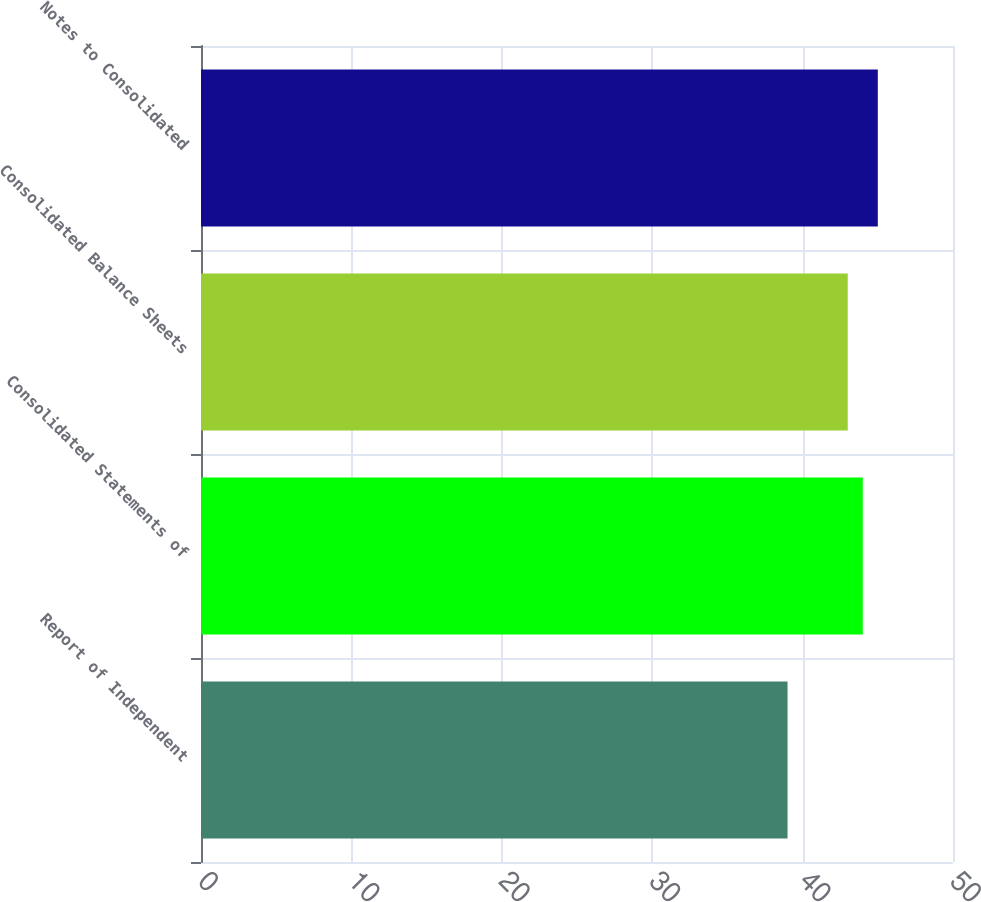<chart> <loc_0><loc_0><loc_500><loc_500><bar_chart><fcel>Report of Independent<fcel>Consolidated Statements of<fcel>Consolidated Balance Sheets<fcel>Notes to Consolidated<nl><fcel>39<fcel>44<fcel>43<fcel>45<nl></chart> 